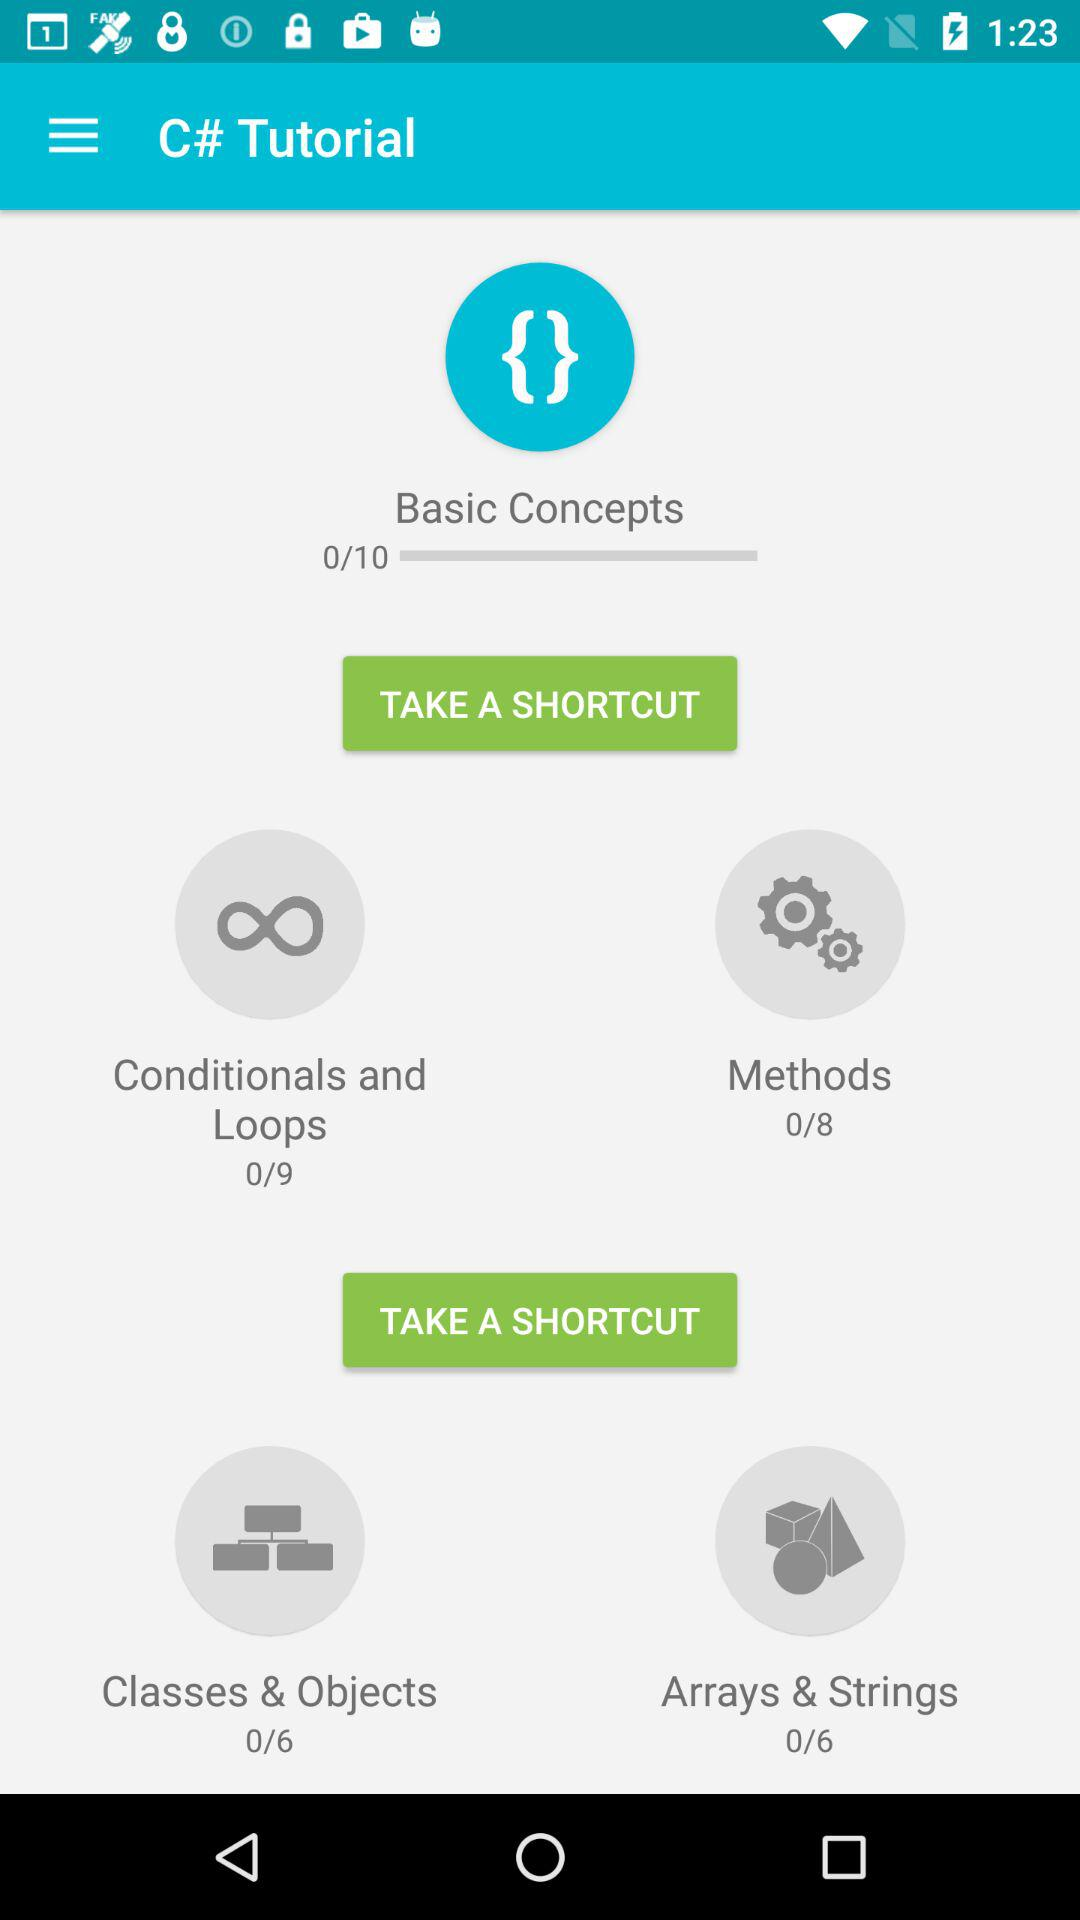How many more lessons are there in the Conditionals and Loops section than the Arrays and Strings section?
Answer the question using a single word or phrase. 3 